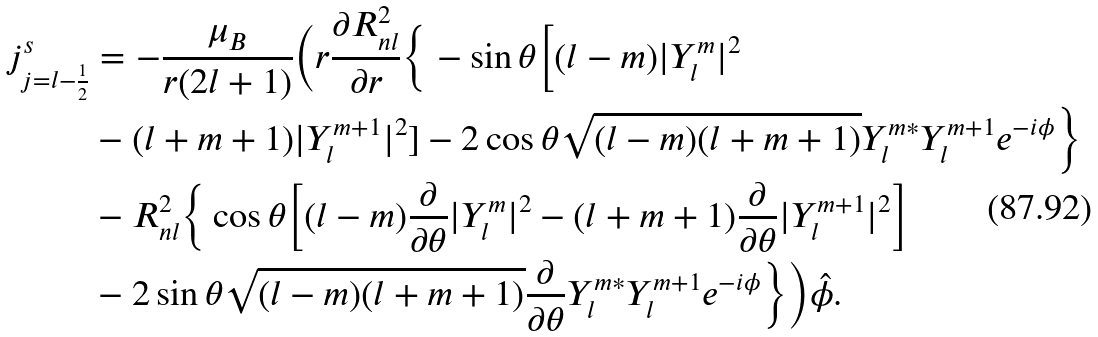<formula> <loc_0><loc_0><loc_500><loc_500>j ^ { s } _ { j = l - \frac { 1 } { 2 } } & = - \frac { \mu _ { B } } { r ( 2 l + 1 ) } \Big ( r \frac { \partial R ^ { 2 } _ { n l } } { \partial r } \Big \{ - \sin \theta \Big [ ( l - m ) | Y ^ { m } _ { l } | ^ { 2 } \\ & - ( l + m + 1 ) | Y ^ { m + 1 } _ { l } | ^ { 2 } ] - 2 \cos \theta \sqrt { ( l - m ) ( l + m + 1 ) } Y ^ { m * } _ { l } Y ^ { m + 1 } _ { l } e ^ { - i \phi } \Big \} \\ & - R ^ { 2 } _ { n l } \Big \{ \cos \theta \Big [ ( l - m ) \frac { \partial } { \partial \theta } | Y ^ { m } _ { l } | ^ { 2 } - ( l + m + 1 ) \frac { \partial } { \partial \theta } | Y ^ { m + 1 } _ { l } | ^ { 2 } \Big ] \\ & - 2 \sin \theta \sqrt { ( l - m ) ( l + m + 1 ) } \frac { \partial } { \partial \theta } Y ^ { m * } _ { l } Y ^ { m + 1 } _ { l } e ^ { - i \phi } \Big \} \Big ) \hat { \phi } .</formula> 